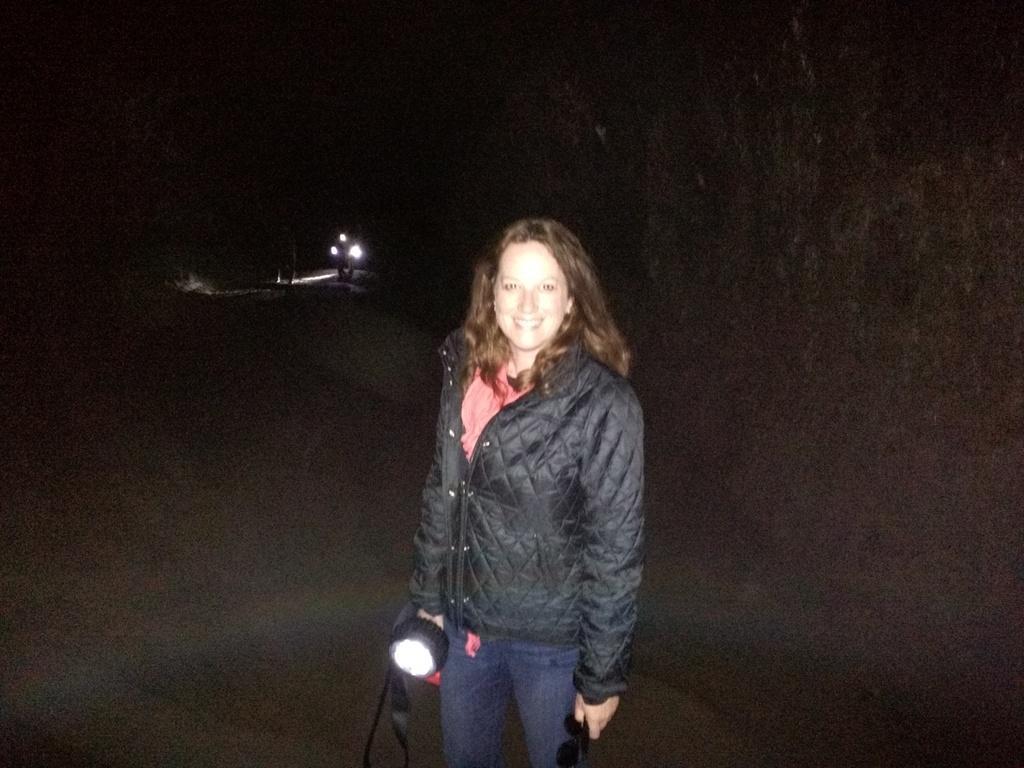How would you summarize this image in a sentence or two? In this image I can see the person standing and holding the torch and the person is wearing black color jacket. In the background I can see few lights. 